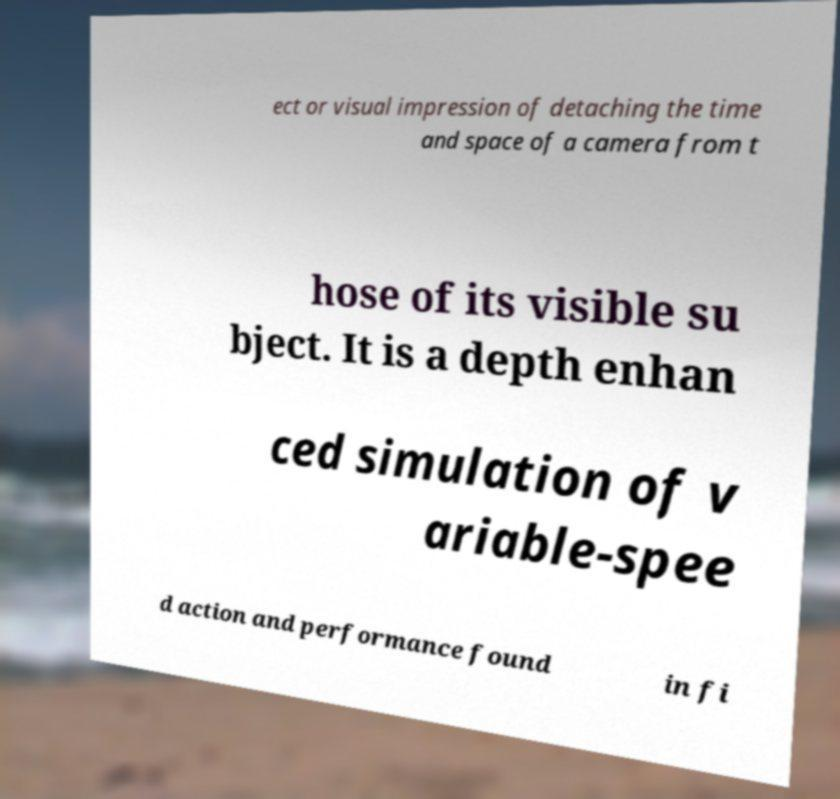Can you accurately transcribe the text from the provided image for me? ect or visual impression of detaching the time and space of a camera from t hose of its visible su bject. It is a depth enhan ced simulation of v ariable-spee d action and performance found in fi 